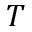<formula> <loc_0><loc_0><loc_500><loc_500>T</formula> 